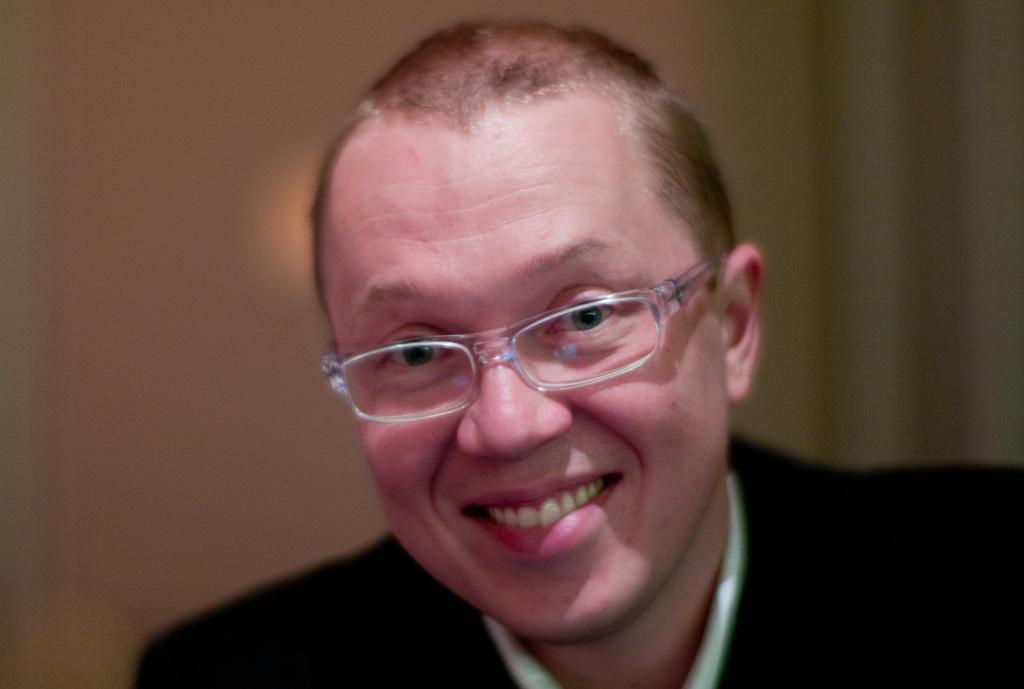Describe this image in one or two sentences. In this image I can see the person and the person is wearing black blazer and white color shirt and I can see the cream color background. 